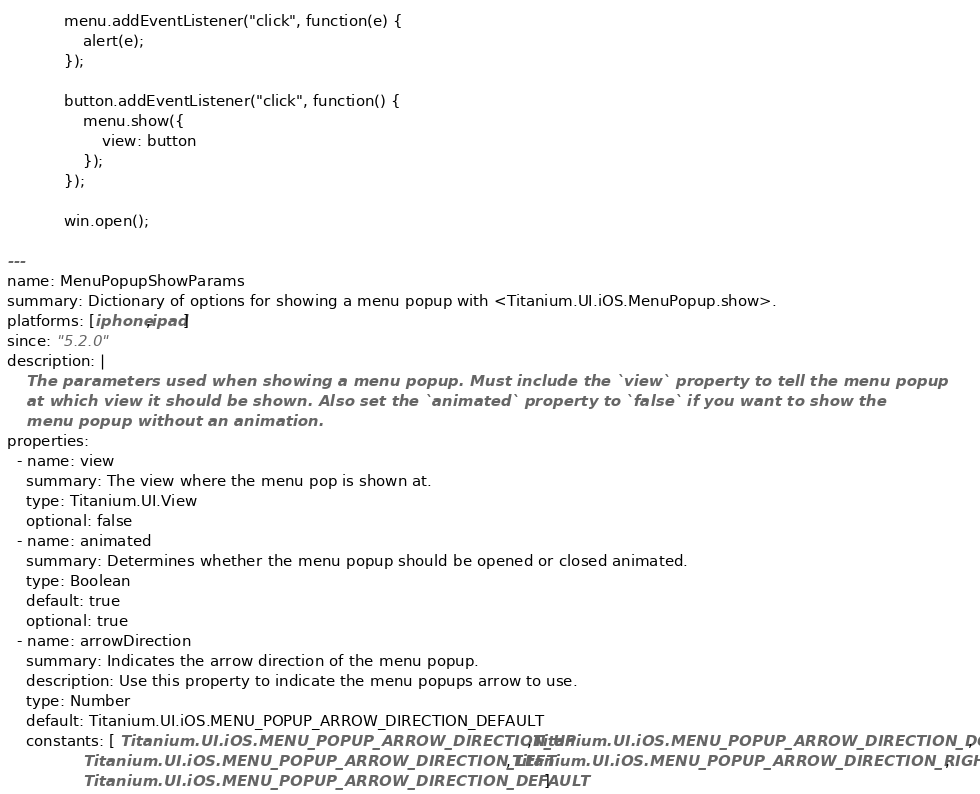Convert code to text. <code><loc_0><loc_0><loc_500><loc_500><_YAML_>
            menu.addEventListener("click", function(e) {
                alert(e);
            });

            button.addEventListener("click", function() {
                menu.show({
            	    view: button
                });
            });

            win.open();

---
name: MenuPopupShowParams
summary: Dictionary of options for showing a menu popup with <Titanium.UI.iOS.MenuPopup.show>.
platforms: [iphone,ipad]
since: "5.2.0"
description: |
    The parameters used when showing a menu popup. Must include the `view` property to tell the menu popup
    at which view it should be shown. Also set the `animated` property to `false` if you want to show the
    menu popup without an animation.
properties:
  - name: view
    summary: The view where the menu pop is shown at.
    type: Titanium.UI.View
    optional: false
  - name: animated
    summary: Determines whether the menu popup should be opened or closed animated.
    type: Boolean
    default: true
    optional: true
  - name: arrowDirection
    summary: Indicates the arrow direction of the menu popup.
    description: Use this property to indicate the menu popups arrow to use. 
    type: Number
    default: Titanium.UI.iOS.MENU_POPUP_ARROW_DIRECTION_DEFAULT
    constants: [ Titanium.UI.iOS.MENU_POPUP_ARROW_DIRECTION_UP,Titanium.UI.iOS.MENU_POPUP_ARROW_DIRECTION_DOWN,
                Titanium.UI.iOS.MENU_POPUP_ARROW_DIRECTION_LEFT,Titanium.UI.iOS.MENU_POPUP_ARROW_DIRECTION_RIGHT,
                Titanium.UI.iOS.MENU_POPUP_ARROW_DIRECTION_DEFAULT ]
</code> 